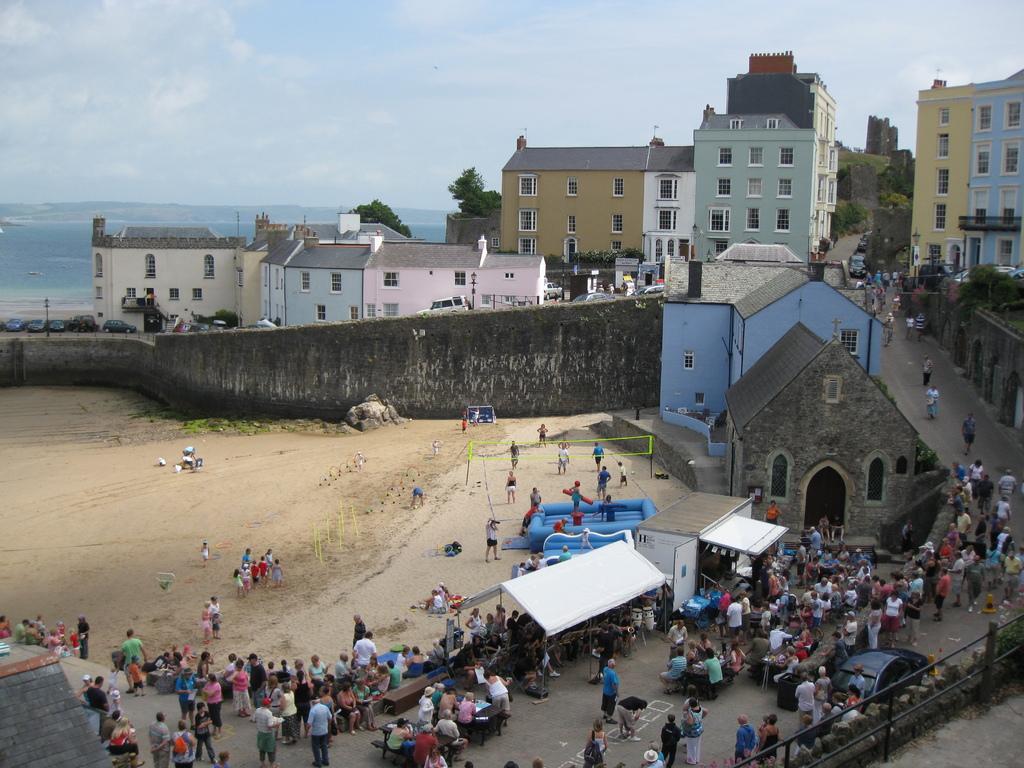Please provide a concise description of this image. In the image we can see there are people standing on the ground and there is a air balloon bed kept on the ground. There are buildings and trees. Behind there is water and there is a clear sky. 